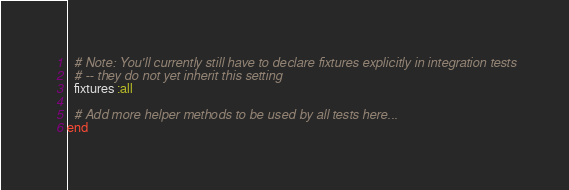<code> <loc_0><loc_0><loc_500><loc_500><_Ruby_>  # Note: You'll currently still have to declare fixtures explicitly in integration tests
  # -- they do not yet inherit this setting
  fixtures :all

  # Add more helper methods to be used by all tests here...
end</code> 